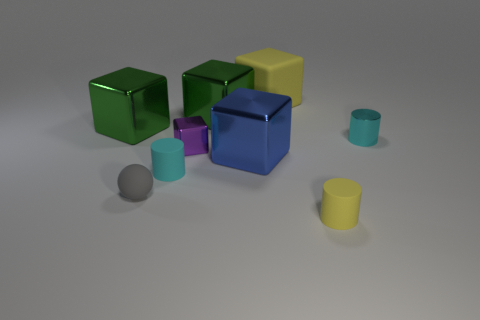Subtract 2 cubes. How many cubes are left? 3 Subtract all blue metallic cubes. How many cubes are left? 4 Subtract all purple blocks. How many blocks are left? 4 Subtract all brown blocks. Subtract all blue cylinders. How many blocks are left? 5 Subtract all blocks. How many objects are left? 4 Subtract 0 purple balls. How many objects are left? 9 Subtract all small yellow metal cylinders. Subtract all cylinders. How many objects are left? 6 Add 5 tiny purple metallic blocks. How many tiny purple metallic blocks are left? 6 Add 8 large blue metal cubes. How many large blue metal cubes exist? 9 